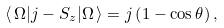<formula> <loc_0><loc_0><loc_500><loc_500>\langle \, \Omega | j - S _ { z } | \Omega \, \rangle = j \left ( 1 - \cos \theta \right ) ,</formula> 